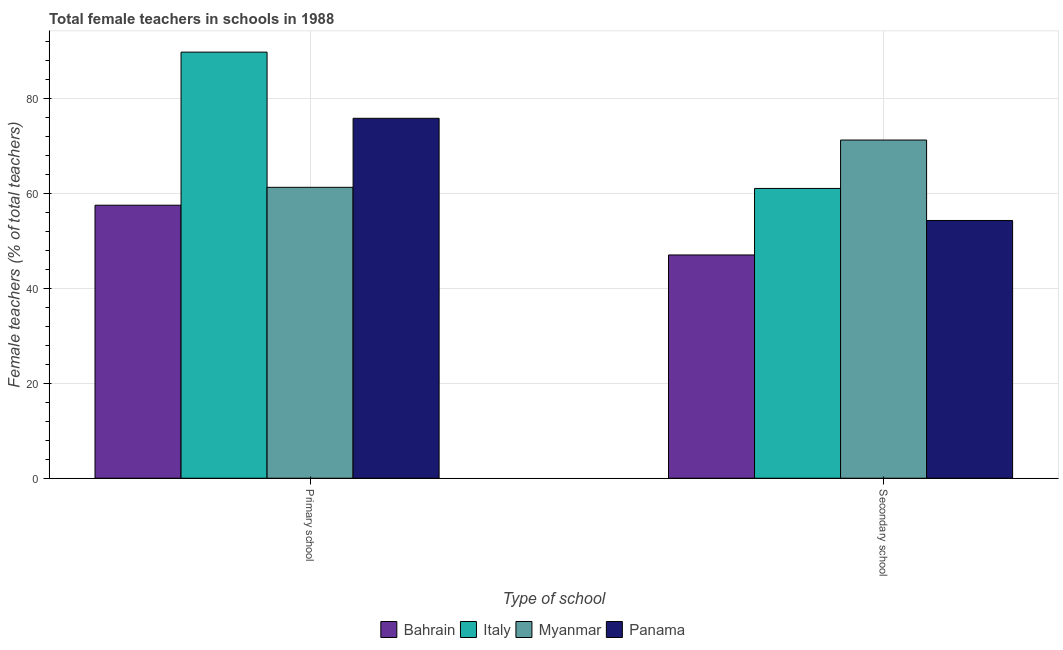How many groups of bars are there?
Give a very brief answer. 2. Are the number of bars per tick equal to the number of legend labels?
Your answer should be compact. Yes. How many bars are there on the 2nd tick from the left?
Offer a terse response. 4. How many bars are there on the 2nd tick from the right?
Keep it short and to the point. 4. What is the label of the 2nd group of bars from the left?
Keep it short and to the point. Secondary school. What is the percentage of female teachers in primary schools in Italy?
Your answer should be compact. 89.79. Across all countries, what is the maximum percentage of female teachers in secondary schools?
Give a very brief answer. 71.27. Across all countries, what is the minimum percentage of female teachers in primary schools?
Your response must be concise. 57.53. In which country was the percentage of female teachers in primary schools minimum?
Your answer should be compact. Bahrain. What is the total percentage of female teachers in primary schools in the graph?
Your answer should be very brief. 284.48. What is the difference between the percentage of female teachers in secondary schools in Bahrain and that in Panama?
Offer a terse response. -7.27. What is the difference between the percentage of female teachers in secondary schools in Myanmar and the percentage of female teachers in primary schools in Panama?
Your answer should be very brief. -4.58. What is the average percentage of female teachers in primary schools per country?
Provide a succinct answer. 71.12. What is the difference between the percentage of female teachers in primary schools and percentage of female teachers in secondary schools in Myanmar?
Ensure brevity in your answer.  -9.96. In how many countries, is the percentage of female teachers in primary schools greater than 60 %?
Your response must be concise. 3. What is the ratio of the percentage of female teachers in secondary schools in Bahrain to that in Myanmar?
Provide a succinct answer. 0.66. Is the percentage of female teachers in secondary schools in Italy less than that in Bahrain?
Your answer should be compact. No. What does the 3rd bar from the left in Secondary school represents?
Your response must be concise. Myanmar. What does the 4th bar from the right in Secondary school represents?
Offer a very short reply. Bahrain. How many bars are there?
Offer a very short reply. 8. How many countries are there in the graph?
Provide a succinct answer. 4. What is the difference between two consecutive major ticks on the Y-axis?
Ensure brevity in your answer.  20. Are the values on the major ticks of Y-axis written in scientific E-notation?
Your answer should be compact. No. Does the graph contain any zero values?
Ensure brevity in your answer.  No. How many legend labels are there?
Provide a short and direct response. 4. What is the title of the graph?
Keep it short and to the point. Total female teachers in schools in 1988. Does "Tonga" appear as one of the legend labels in the graph?
Your answer should be very brief. No. What is the label or title of the X-axis?
Give a very brief answer. Type of school. What is the label or title of the Y-axis?
Offer a terse response. Female teachers (% of total teachers). What is the Female teachers (% of total teachers) of Bahrain in Primary school?
Offer a terse response. 57.53. What is the Female teachers (% of total teachers) in Italy in Primary school?
Your answer should be compact. 89.79. What is the Female teachers (% of total teachers) of Myanmar in Primary school?
Provide a short and direct response. 61.3. What is the Female teachers (% of total teachers) of Panama in Primary school?
Keep it short and to the point. 75.85. What is the Female teachers (% of total teachers) in Bahrain in Secondary school?
Your answer should be very brief. 47.05. What is the Female teachers (% of total teachers) in Italy in Secondary school?
Your response must be concise. 61.07. What is the Female teachers (% of total teachers) of Myanmar in Secondary school?
Ensure brevity in your answer.  71.27. What is the Female teachers (% of total teachers) in Panama in Secondary school?
Provide a succinct answer. 54.32. Across all Type of school, what is the maximum Female teachers (% of total teachers) of Bahrain?
Provide a short and direct response. 57.53. Across all Type of school, what is the maximum Female teachers (% of total teachers) in Italy?
Give a very brief answer. 89.79. Across all Type of school, what is the maximum Female teachers (% of total teachers) of Myanmar?
Ensure brevity in your answer.  71.27. Across all Type of school, what is the maximum Female teachers (% of total teachers) of Panama?
Your response must be concise. 75.85. Across all Type of school, what is the minimum Female teachers (% of total teachers) in Bahrain?
Keep it short and to the point. 47.05. Across all Type of school, what is the minimum Female teachers (% of total teachers) of Italy?
Offer a terse response. 61.07. Across all Type of school, what is the minimum Female teachers (% of total teachers) in Myanmar?
Give a very brief answer. 61.3. Across all Type of school, what is the minimum Female teachers (% of total teachers) of Panama?
Your answer should be very brief. 54.32. What is the total Female teachers (% of total teachers) of Bahrain in the graph?
Keep it short and to the point. 104.58. What is the total Female teachers (% of total teachers) of Italy in the graph?
Keep it short and to the point. 150.86. What is the total Female teachers (% of total teachers) of Myanmar in the graph?
Provide a succinct answer. 132.57. What is the total Female teachers (% of total teachers) in Panama in the graph?
Provide a short and direct response. 130.17. What is the difference between the Female teachers (% of total teachers) of Bahrain in Primary school and that in Secondary school?
Give a very brief answer. 10.49. What is the difference between the Female teachers (% of total teachers) of Italy in Primary school and that in Secondary school?
Your answer should be compact. 28.72. What is the difference between the Female teachers (% of total teachers) of Myanmar in Primary school and that in Secondary school?
Ensure brevity in your answer.  -9.96. What is the difference between the Female teachers (% of total teachers) of Panama in Primary school and that in Secondary school?
Offer a very short reply. 21.53. What is the difference between the Female teachers (% of total teachers) in Bahrain in Primary school and the Female teachers (% of total teachers) in Italy in Secondary school?
Offer a very short reply. -3.54. What is the difference between the Female teachers (% of total teachers) of Bahrain in Primary school and the Female teachers (% of total teachers) of Myanmar in Secondary school?
Your answer should be compact. -13.73. What is the difference between the Female teachers (% of total teachers) in Bahrain in Primary school and the Female teachers (% of total teachers) in Panama in Secondary school?
Make the answer very short. 3.22. What is the difference between the Female teachers (% of total teachers) of Italy in Primary school and the Female teachers (% of total teachers) of Myanmar in Secondary school?
Ensure brevity in your answer.  18.53. What is the difference between the Female teachers (% of total teachers) in Italy in Primary school and the Female teachers (% of total teachers) in Panama in Secondary school?
Make the answer very short. 35.47. What is the difference between the Female teachers (% of total teachers) of Myanmar in Primary school and the Female teachers (% of total teachers) of Panama in Secondary school?
Provide a short and direct response. 6.99. What is the average Female teachers (% of total teachers) of Bahrain per Type of school?
Provide a succinct answer. 52.29. What is the average Female teachers (% of total teachers) in Italy per Type of school?
Offer a terse response. 75.43. What is the average Female teachers (% of total teachers) in Myanmar per Type of school?
Keep it short and to the point. 66.29. What is the average Female teachers (% of total teachers) in Panama per Type of school?
Make the answer very short. 65.08. What is the difference between the Female teachers (% of total teachers) of Bahrain and Female teachers (% of total teachers) of Italy in Primary school?
Ensure brevity in your answer.  -32.26. What is the difference between the Female teachers (% of total teachers) of Bahrain and Female teachers (% of total teachers) of Myanmar in Primary school?
Make the answer very short. -3.77. What is the difference between the Female teachers (% of total teachers) in Bahrain and Female teachers (% of total teachers) in Panama in Primary school?
Offer a very short reply. -18.31. What is the difference between the Female teachers (% of total teachers) in Italy and Female teachers (% of total teachers) in Myanmar in Primary school?
Provide a short and direct response. 28.49. What is the difference between the Female teachers (% of total teachers) of Italy and Female teachers (% of total teachers) of Panama in Primary school?
Offer a terse response. 13.95. What is the difference between the Female teachers (% of total teachers) of Myanmar and Female teachers (% of total teachers) of Panama in Primary school?
Your answer should be compact. -14.54. What is the difference between the Female teachers (% of total teachers) in Bahrain and Female teachers (% of total teachers) in Italy in Secondary school?
Provide a succinct answer. -14.02. What is the difference between the Female teachers (% of total teachers) of Bahrain and Female teachers (% of total teachers) of Myanmar in Secondary school?
Ensure brevity in your answer.  -24.22. What is the difference between the Female teachers (% of total teachers) in Bahrain and Female teachers (% of total teachers) in Panama in Secondary school?
Offer a very short reply. -7.27. What is the difference between the Female teachers (% of total teachers) in Italy and Female teachers (% of total teachers) in Myanmar in Secondary school?
Provide a short and direct response. -10.2. What is the difference between the Female teachers (% of total teachers) of Italy and Female teachers (% of total teachers) of Panama in Secondary school?
Provide a short and direct response. 6.75. What is the difference between the Female teachers (% of total teachers) of Myanmar and Female teachers (% of total teachers) of Panama in Secondary school?
Offer a very short reply. 16.95. What is the ratio of the Female teachers (% of total teachers) in Bahrain in Primary school to that in Secondary school?
Give a very brief answer. 1.22. What is the ratio of the Female teachers (% of total teachers) in Italy in Primary school to that in Secondary school?
Provide a succinct answer. 1.47. What is the ratio of the Female teachers (% of total teachers) in Myanmar in Primary school to that in Secondary school?
Keep it short and to the point. 0.86. What is the ratio of the Female teachers (% of total teachers) in Panama in Primary school to that in Secondary school?
Provide a short and direct response. 1.4. What is the difference between the highest and the second highest Female teachers (% of total teachers) in Bahrain?
Keep it short and to the point. 10.49. What is the difference between the highest and the second highest Female teachers (% of total teachers) of Italy?
Your answer should be compact. 28.72. What is the difference between the highest and the second highest Female teachers (% of total teachers) of Myanmar?
Offer a very short reply. 9.96. What is the difference between the highest and the second highest Female teachers (% of total teachers) in Panama?
Provide a short and direct response. 21.53. What is the difference between the highest and the lowest Female teachers (% of total teachers) in Bahrain?
Your answer should be very brief. 10.49. What is the difference between the highest and the lowest Female teachers (% of total teachers) of Italy?
Ensure brevity in your answer.  28.72. What is the difference between the highest and the lowest Female teachers (% of total teachers) of Myanmar?
Offer a terse response. 9.96. What is the difference between the highest and the lowest Female teachers (% of total teachers) of Panama?
Provide a succinct answer. 21.53. 